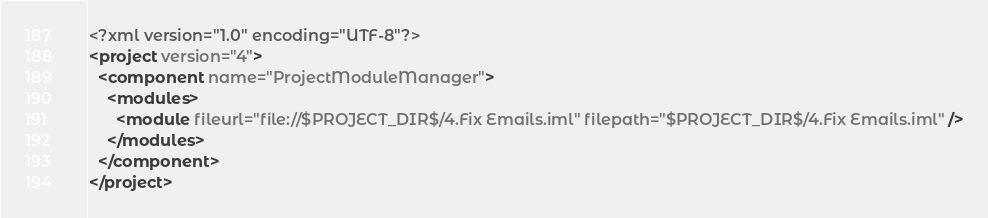Convert code to text. <code><loc_0><loc_0><loc_500><loc_500><_XML_><?xml version="1.0" encoding="UTF-8"?>
<project version="4">
  <component name="ProjectModuleManager">
    <modules>
      <module fileurl="file://$PROJECT_DIR$/4.Fix Emails.iml" filepath="$PROJECT_DIR$/4.Fix Emails.iml" />
    </modules>
  </component>
</project></code> 